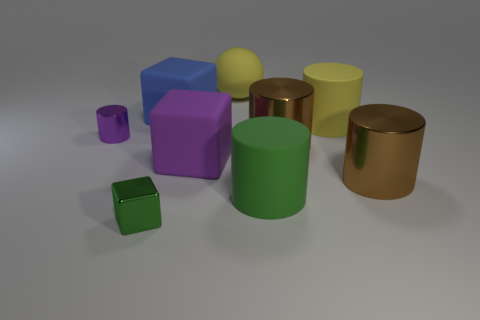What is the shape of the object that is the same color as the tiny block?
Make the answer very short. Cylinder. Is there a big brown cylinder?
Keep it short and to the point. Yes. What number of things are the same size as the yellow sphere?
Provide a short and direct response. 6. What number of things are both in front of the sphere and right of the small green thing?
Provide a short and direct response. 6. Do the green object on the right side of the purple rubber cube and the purple shiny cylinder have the same size?
Keep it short and to the point. No. Are there any big objects of the same color as the big rubber sphere?
Give a very brief answer. Yes. There is a block that is made of the same material as the small cylinder; what is its size?
Give a very brief answer. Small. Are there more brown shiny cylinders left of the big purple cube than yellow matte balls in front of the large yellow sphere?
Provide a succinct answer. No. How many other objects are there of the same material as the green block?
Keep it short and to the point. 3. Do the big yellow thing in front of the rubber ball and the purple cylinder have the same material?
Your response must be concise. No. 